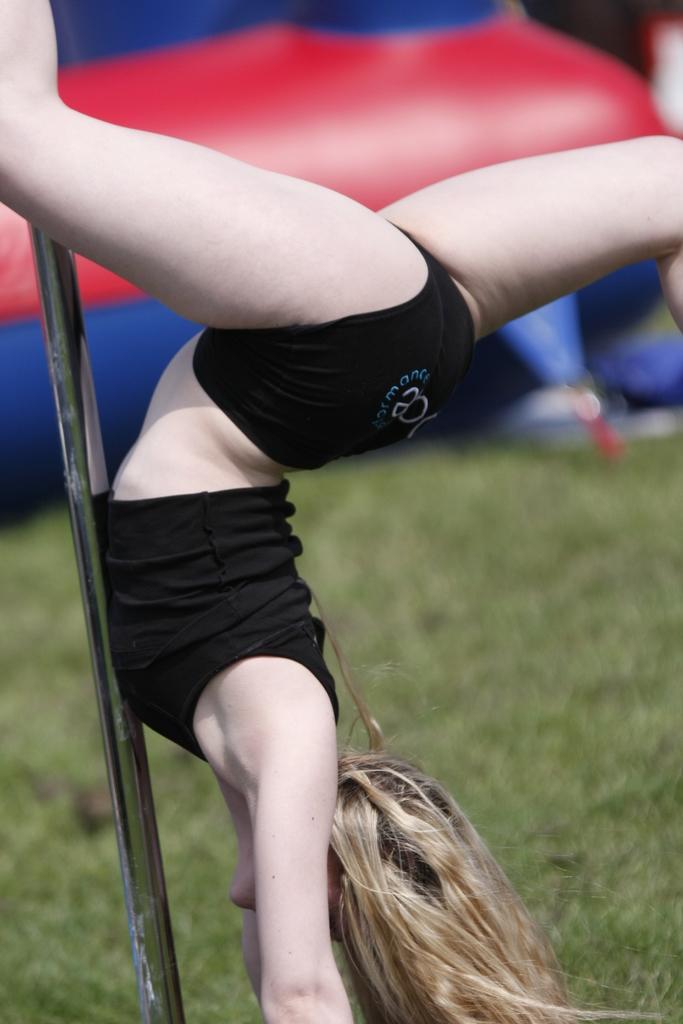Describe this image in one or two sentences. In the middle of the image we can see a pole and a woman is doing something. Behind her we can see grass and balloon. 